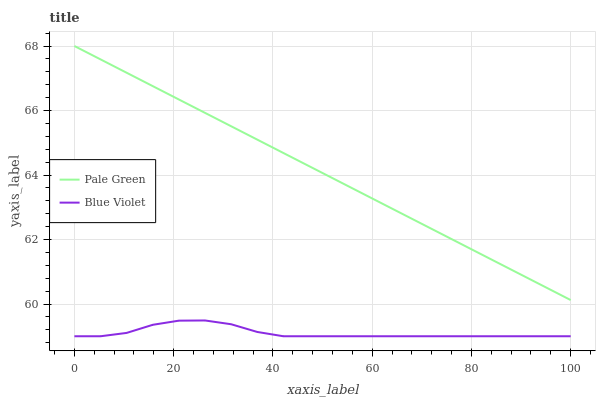Does Blue Violet have the minimum area under the curve?
Answer yes or no. Yes. Does Pale Green have the maximum area under the curve?
Answer yes or no. Yes. Does Blue Violet have the maximum area under the curve?
Answer yes or no. No. Is Pale Green the smoothest?
Answer yes or no. Yes. Is Blue Violet the roughest?
Answer yes or no. Yes. Is Blue Violet the smoothest?
Answer yes or no. No. Does Blue Violet have the lowest value?
Answer yes or no. Yes. Does Pale Green have the highest value?
Answer yes or no. Yes. Does Blue Violet have the highest value?
Answer yes or no. No. Is Blue Violet less than Pale Green?
Answer yes or no. Yes. Is Pale Green greater than Blue Violet?
Answer yes or no. Yes. Does Blue Violet intersect Pale Green?
Answer yes or no. No. 